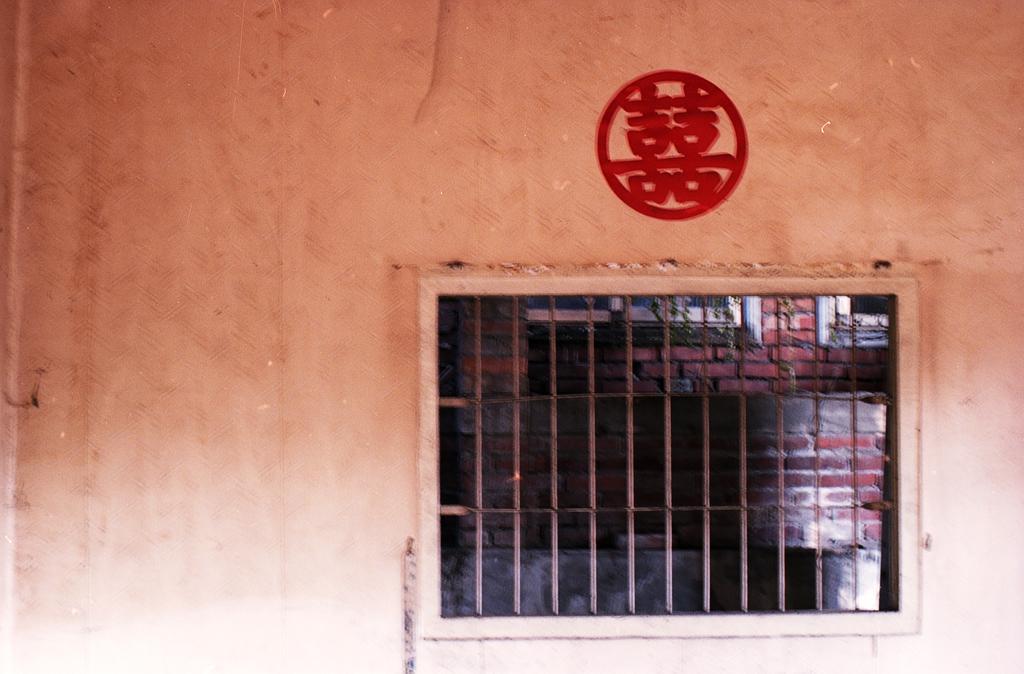Could you give a brief overview of what you see in this image? In this picture we can see symbol on the wall and window, through window we can see wall and windows. 